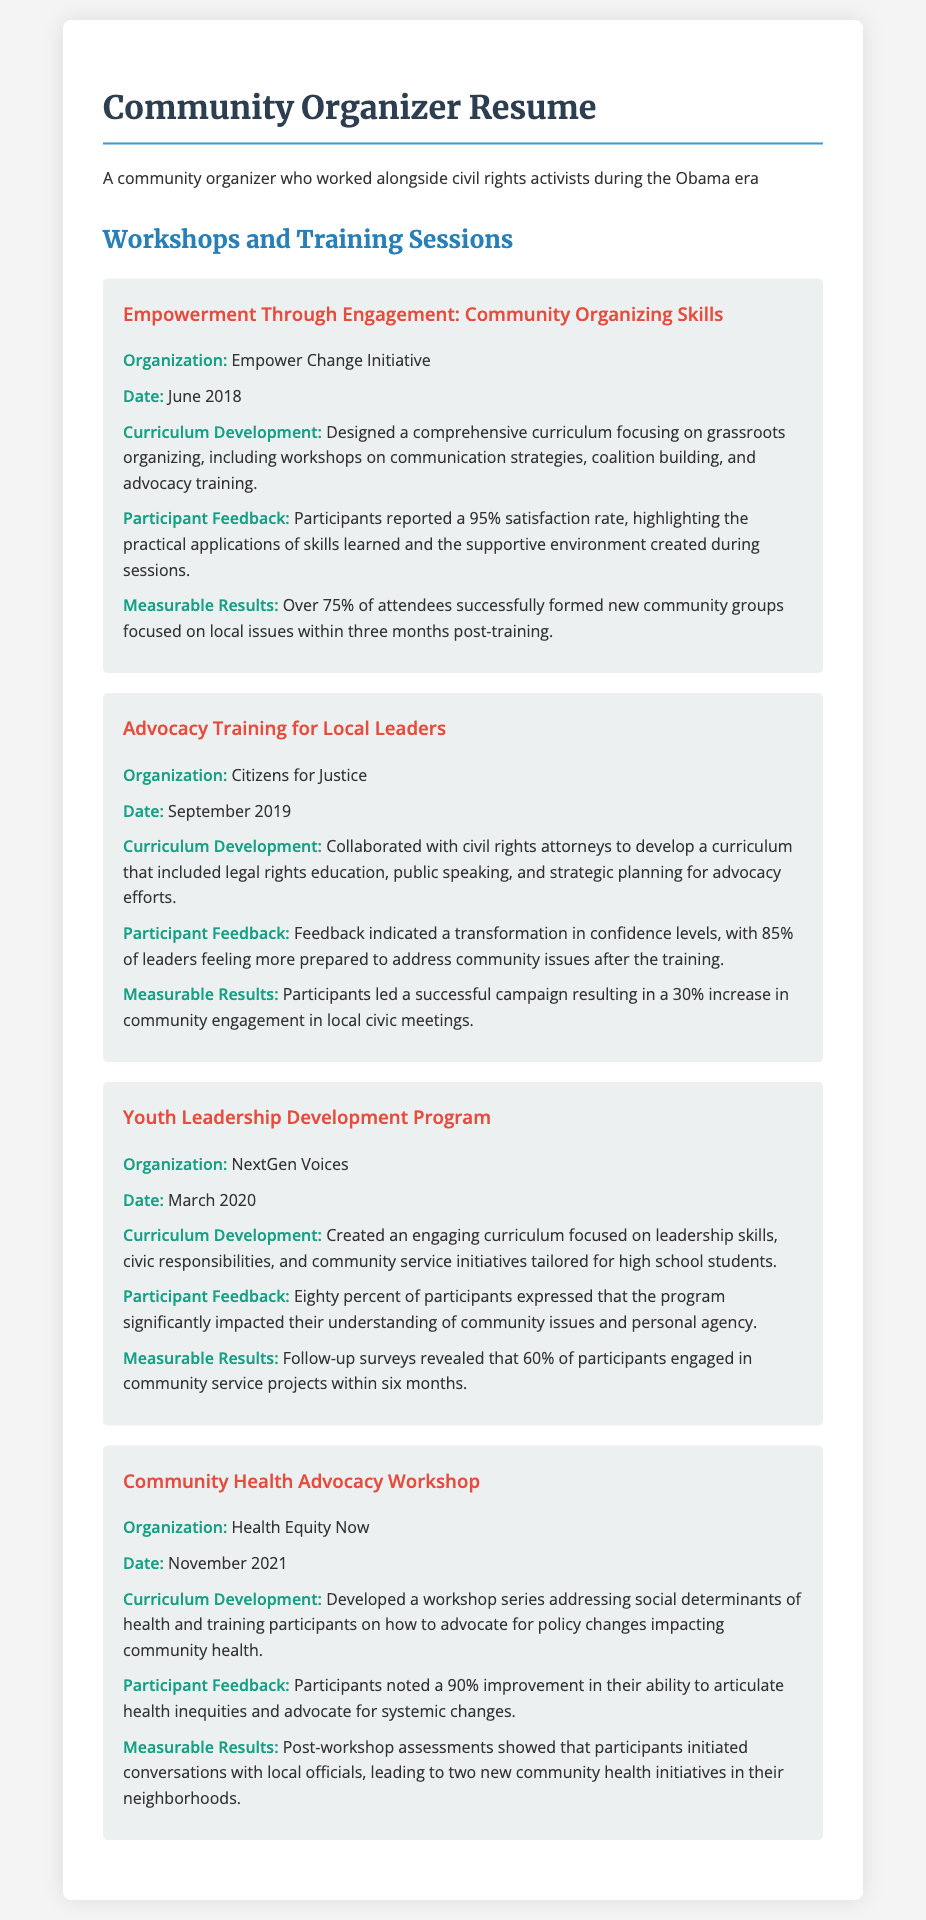What was the date of the "Empowerment Through Engagement" workshop? The date is specified in the workshop details, listed under "Date" for that workshop.
Answer: June 2018 What percentage of participants reported satisfaction in the "Advocacy Training for Local Leaders"? This refers to the feedback section noting the percentage of participants satisfied with the training.
Answer: 85% What organization conducted the "Youth Leadership Development Program"? This information is found in the workshop details under the organization section.
Answer: NextGen Voices What curriculum focus was developed for the "Community Health Advocacy Workshop"? The curriculum focus is mentioned in the curriculum development section for this workshop, which highlights the main topics covered.
Answer: Social determinants of health What was the measurable result of the "Empowerment Through Engagement" workshop? The measurable results detail the outcomes of the workshop, specifically the percentage of attendees forming new groups.
Answer: 75% What significant shift did participants experience in confidence during the "Advocacy Training for Local Leaders"? This is found in the feedback section, detailing changes in participants' confidence levels.
Answer: Transformation What was the impact reported by participants of the "Youth Leadership Development Program"? This can be located in the feedback section illustrating the program's effect on participants' understanding.
Answer: Significantly impacted How many new community health initiatives were initiated after the "Community Health Advocacy Workshop"? The measurable results section outlines the number of new initiatives that resulted from the workshop.
Answer: Two 